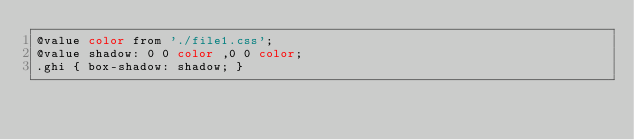<code> <loc_0><loc_0><loc_500><loc_500><_CSS_>@value color from './file1.css';
@value shadow: 0 0 color ,0 0 color;
.ghi { box-shadow: shadow; }
</code> 